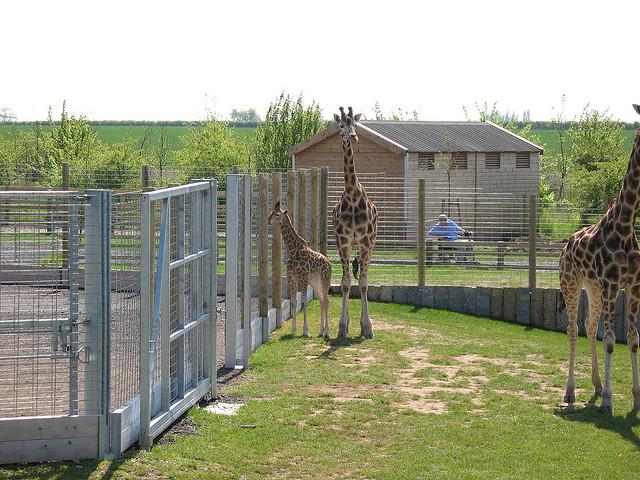Are the animals wild?
Quick response, please. No. What material is the fence made of?
Short answer required. Metal. Does the grass slope?
Concise answer only. Yes. Are there any people?
Concise answer only. Yes. 